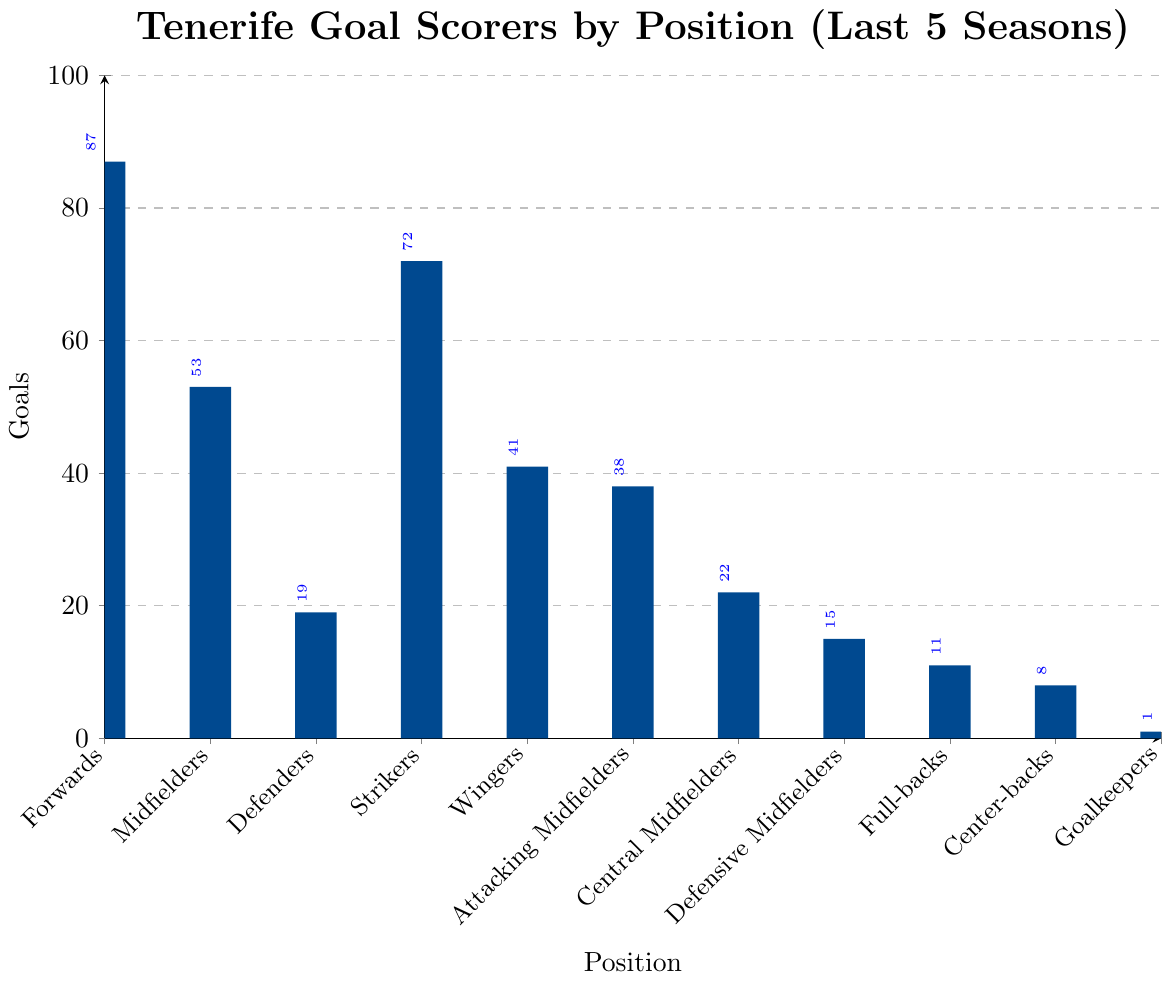What position scored the highest number of goals? The figure shows bars for different positions, and the tallest bar corresponds to the "Forwards" position with 87 goals.
Answer: Forwards What is the total number of goals scored by midfielders (including Attacking Midfielders, Central Midfielders, and Defensive Midfielders)? Add the goals for Midfielders (53), Attacking Midfielders (38), Central Midfielders (22), and Defensive Midfielders (15). 53 + 38 + 22 + 15 = 128.
Answer: 128 Which position has scored fewer goals: Wingers or Full-backs? Compare the height of the bars for Wingers (41 goals) and Full-backs (11 goals).
Answer: Full-backs How many more goals have Strikers scored compared to Defenders? Subtract the number of goals scored by Defenders (19) from the goals scored by Strikers (72). 72 - 19 = 53.
Answer: 53 What is the percentage of goals scored by Goalkeepers out of the total goals? Sum total goals scored by all positions and calculate the percentage of the Goalkeepers’ goals: 
(87 + 53 + 19 + 72 + 41 + 38 + 22 + 15 + 11 + 8 + 1) = 367. 
The percentage is (1 / 367) * 100 ≈ 0.27%.
Answer: 0.27% Which had more goals: Forwards or the combined total of Defenders and Strikers? Calculate the combined total of Defenders and Strikers: 19 + 72 = 91. Compare this with Forwards’ 87 goals. 91 - 87 = 4 more goals for the combined total of Defenders and Strikers.
Answer: Combined total of Defenders and Strikers What is the ratio of goals scored by Center-backs to Full-backs? Find the number of goals for Center-backs (8) and Full-backs (11) and express this as a ratio: 8:11.
Answer: 8:11 If external agents set a threshold at 20 goals to be considered 'high-scoring', how many positions meet this criterion? Count the positions with 20 or more goals: Forwards (87), Midfielders (53), Strikers (72), Wingers (41), and Attacking Midfielders (38), Central Midfielders (22). That makes 6 positions.
Answer: 6 What is the difference in goals between the position with the second-highest and the third-highest goals? Identify the second-highest (Strikers, 72) and third-highest (Midfielders, 53) goal-scorers, then subtract: 72 - 53 = 19.
Answer: 19 Which position scored the least number of goals? The shortest bar in the figure corresponds to the "Goalkeepers" with 1 goal.
Answer: Goalkeepers 